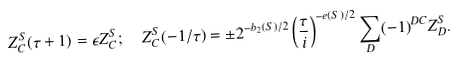Convert formula to latex. <formula><loc_0><loc_0><loc_500><loc_500>Z _ { C } ^ { S } ( \tau + 1 ) & = \epsilon Z _ { C } ^ { S } ; \quad Z _ { C } ^ { S } ( - 1 / \tau ) = \pm 2 ^ { - b _ { 2 } ( S ) / 2 } \left ( \frac { \tau } { i } \right ) ^ { - e ( S ) / 2 } \sum _ { D } ( - 1 ) ^ { D C } Z _ { D } ^ { S } .</formula> 